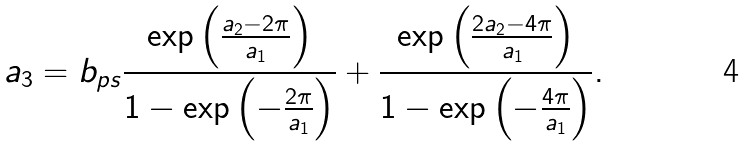<formula> <loc_0><loc_0><loc_500><loc_500>a _ { 3 } = b _ { p s } \frac { \exp \left ( \frac { a _ { 2 } - 2 \pi } { a _ { 1 } } \right ) } { 1 - \exp \left ( - \frac { 2 \pi } { a _ { 1 } } \right ) } + \frac { \exp \left ( \frac { 2 a _ { 2 } - 4 \pi } { a _ { 1 } } \right ) } { 1 - \exp \left ( - \frac { 4 \pi } { a _ { 1 } } \right ) } .</formula> 